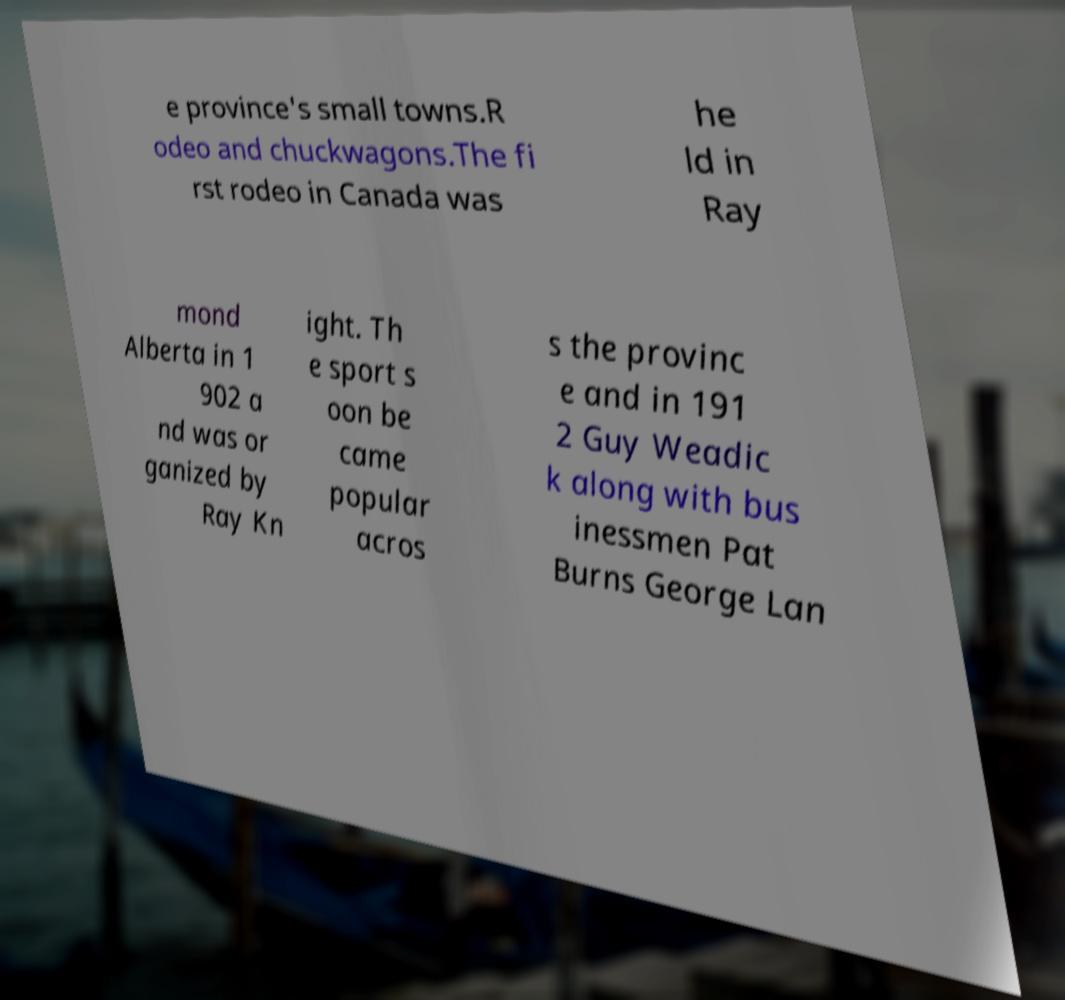Could you assist in decoding the text presented in this image and type it out clearly? e province's small towns.R odeo and chuckwagons.The fi rst rodeo in Canada was he ld in Ray mond Alberta in 1 902 a nd was or ganized by Ray Kn ight. Th e sport s oon be came popular acros s the provinc e and in 191 2 Guy Weadic k along with bus inessmen Pat Burns George Lan 